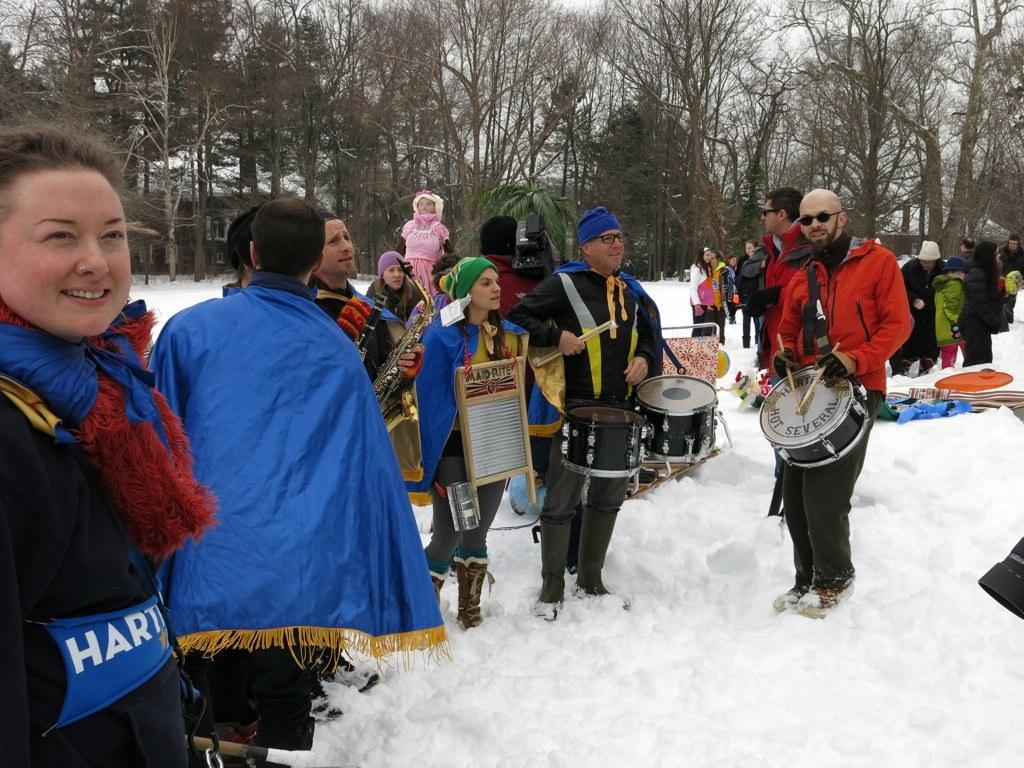<image>
Render a clear and concise summary of the photo. A man with a drum is part of a group of people in the snow that play for the Hartford Hot Several. 